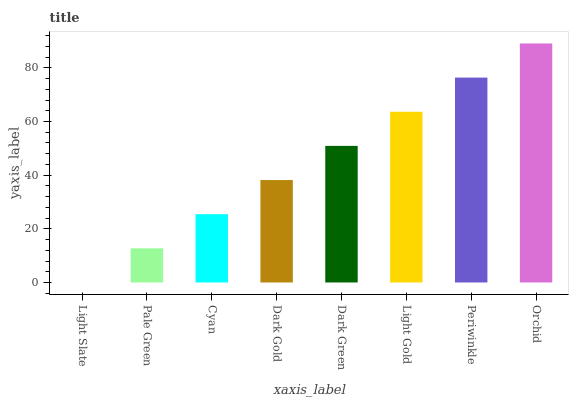Is Pale Green the minimum?
Answer yes or no. No. Is Pale Green the maximum?
Answer yes or no. No. Is Pale Green greater than Light Slate?
Answer yes or no. Yes. Is Light Slate less than Pale Green?
Answer yes or no. Yes. Is Light Slate greater than Pale Green?
Answer yes or no. No. Is Pale Green less than Light Slate?
Answer yes or no. No. Is Dark Green the high median?
Answer yes or no. Yes. Is Dark Gold the low median?
Answer yes or no. Yes. Is Light Slate the high median?
Answer yes or no. No. Is Periwinkle the low median?
Answer yes or no. No. 